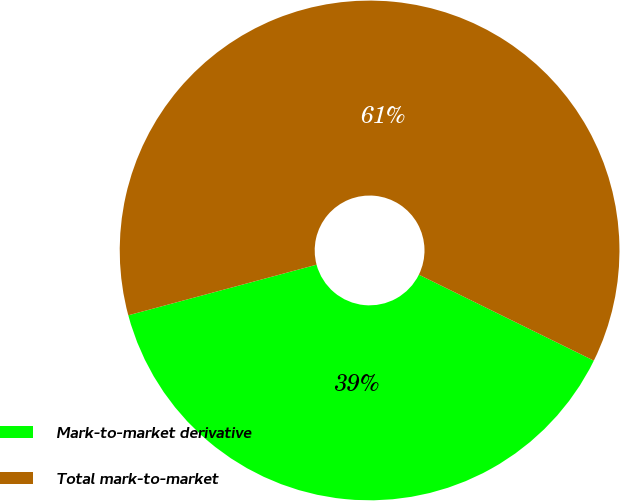Convert chart. <chart><loc_0><loc_0><loc_500><loc_500><pie_chart><fcel>Mark-to-market derivative<fcel>Total mark-to-market<nl><fcel>38.55%<fcel>61.45%<nl></chart> 